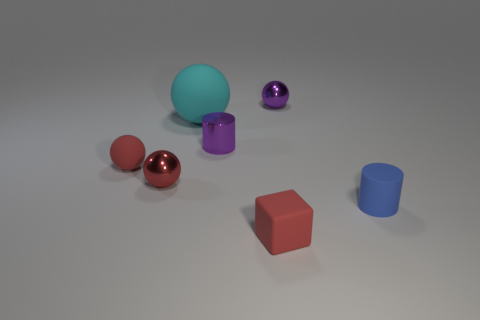Is the number of small purple balls that are behind the red rubber cube greater than the number of cyan balls on the right side of the small matte cylinder?
Keep it short and to the point. Yes. Is there a small red shiny thing that has the same shape as the blue thing?
Your answer should be very brief. No. The red metallic object that is the same size as the matte cylinder is what shape?
Keep it short and to the point. Sphere. There is a red matte object that is in front of the small red matte ball; what shape is it?
Your answer should be very brief. Cube. Are there fewer small red rubber blocks that are to the left of the large cyan matte thing than small matte balls that are right of the tiny red metal sphere?
Your answer should be very brief. No. Does the red matte sphere have the same size as the metallic object left of the big cyan matte object?
Provide a succinct answer. Yes. How many purple cylinders have the same size as the cyan matte ball?
Offer a very short reply. 0. There is a tiny ball that is made of the same material as the cyan thing; what is its color?
Make the answer very short. Red. Is the number of tiny red rubber cubes greater than the number of tiny green spheres?
Keep it short and to the point. Yes. Does the tiny purple ball have the same material as the small blue thing?
Ensure brevity in your answer.  No. 